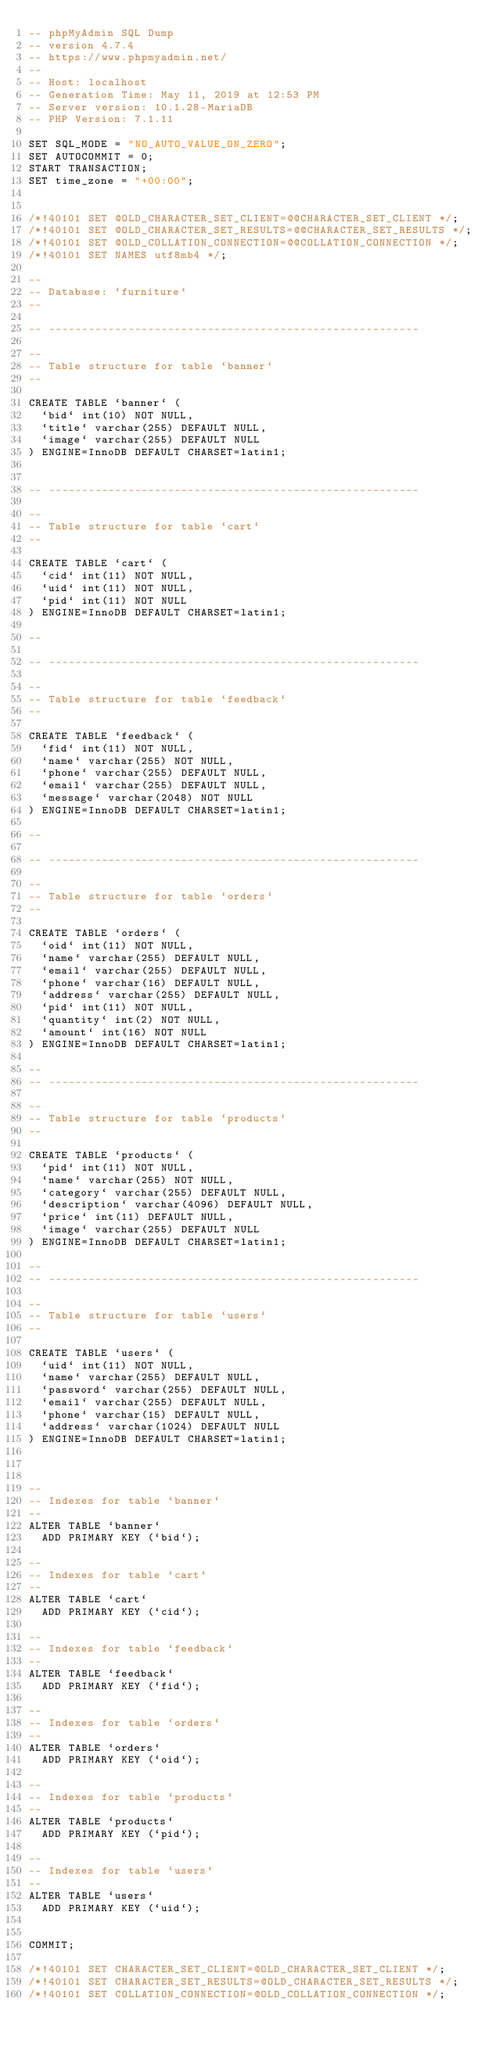Convert code to text. <code><loc_0><loc_0><loc_500><loc_500><_SQL_>-- phpMyAdmin SQL Dump
-- version 4.7.4
-- https://www.phpmyadmin.net/
--
-- Host: localhost
-- Generation Time: May 11, 2019 at 12:53 PM
-- Server version: 10.1.28-MariaDB
-- PHP Version: 7.1.11

SET SQL_MODE = "NO_AUTO_VALUE_ON_ZERO";
SET AUTOCOMMIT = 0;
START TRANSACTION;
SET time_zone = "+00:00";


/*!40101 SET @OLD_CHARACTER_SET_CLIENT=@@CHARACTER_SET_CLIENT */;
/*!40101 SET @OLD_CHARACTER_SET_RESULTS=@@CHARACTER_SET_RESULTS */;
/*!40101 SET @OLD_COLLATION_CONNECTION=@@COLLATION_CONNECTION */;
/*!40101 SET NAMES utf8mb4 */;

--
-- Database: `furniture`
--

-- --------------------------------------------------------

--
-- Table structure for table `banner`
--

CREATE TABLE `banner` (
  `bid` int(10) NOT NULL,
  `title` varchar(255) DEFAULT NULL,
  `image` varchar(255) DEFAULT NULL
) ENGINE=InnoDB DEFAULT CHARSET=latin1;


-- --------------------------------------------------------

--
-- Table structure for table `cart`
--

CREATE TABLE `cart` (
  `cid` int(11) NOT NULL,
  `uid` int(11) NOT NULL,
  `pid` int(11) NOT NULL
) ENGINE=InnoDB DEFAULT CHARSET=latin1;

--

-- --------------------------------------------------------

--
-- Table structure for table `feedback`
--

CREATE TABLE `feedback` (
  `fid` int(11) NOT NULL,
  `name` varchar(255) NOT NULL,
  `phone` varchar(255) DEFAULT NULL,
  `email` varchar(255) DEFAULT NULL,
  `message` varchar(2048) NOT NULL
) ENGINE=InnoDB DEFAULT CHARSET=latin1;

--

-- --------------------------------------------------------

--
-- Table structure for table `orders`
--

CREATE TABLE `orders` (
  `oid` int(11) NOT NULL,
  `name` varchar(255) DEFAULT NULL,
  `email` varchar(255) DEFAULT NULL,
  `phone` varchar(16) DEFAULT NULL,
  `address` varchar(255) DEFAULT NULL,
  `pid` int(11) NOT NULL,
  `quantity` int(2) NOT NULL,
  `amount` int(16) NOT NULL
) ENGINE=InnoDB DEFAULT CHARSET=latin1;

--
-- --------------------------------------------------------

--
-- Table structure for table `products`
--

CREATE TABLE `products` (
  `pid` int(11) NOT NULL,
  `name` varchar(255) NOT NULL,
  `category` varchar(255) DEFAULT NULL,
  `description` varchar(4096) DEFAULT NULL,
  `price` int(11) DEFAULT NULL,
  `image` varchar(255) DEFAULT NULL
) ENGINE=InnoDB DEFAULT CHARSET=latin1;

--
-- --------------------------------------------------------

--
-- Table structure for table `users`
--

CREATE TABLE `users` (
  `uid` int(11) NOT NULL,
  `name` varchar(255) DEFAULT NULL,
  `password` varchar(255) DEFAULT NULL,
  `email` varchar(255) DEFAULT NULL,
  `phone` varchar(15) DEFAULT NULL,
  `address` varchar(1024) DEFAULT NULL
) ENGINE=InnoDB DEFAULT CHARSET=latin1;



--
-- Indexes for table `banner`
--
ALTER TABLE `banner`
  ADD PRIMARY KEY (`bid`);

--
-- Indexes for table `cart`
--
ALTER TABLE `cart`
  ADD PRIMARY KEY (`cid`);

--
-- Indexes for table `feedback`
--
ALTER TABLE `feedback`
  ADD PRIMARY KEY (`fid`);

--
-- Indexes for table `orders`
--
ALTER TABLE `orders`
  ADD PRIMARY KEY (`oid`);

--
-- Indexes for table `products`
--
ALTER TABLE `products`
  ADD PRIMARY KEY (`pid`);

--
-- Indexes for table `users`
--
ALTER TABLE `users`
  ADD PRIMARY KEY (`uid`);


COMMIT;

/*!40101 SET CHARACTER_SET_CLIENT=@OLD_CHARACTER_SET_CLIENT */;
/*!40101 SET CHARACTER_SET_RESULTS=@OLD_CHARACTER_SET_RESULTS */;
/*!40101 SET COLLATION_CONNECTION=@OLD_COLLATION_CONNECTION */;
</code> 